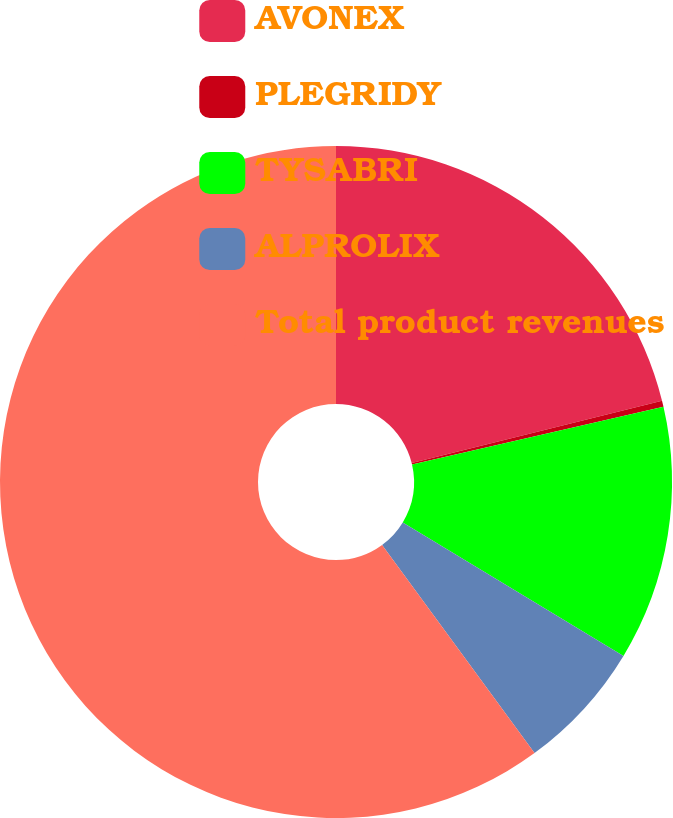Convert chart to OTSL. <chart><loc_0><loc_0><loc_500><loc_500><pie_chart><fcel>AVONEX<fcel>PLEGRIDY<fcel>TYSABRI<fcel>ALPROLIX<fcel>Total product revenues<nl><fcel>21.11%<fcel>0.3%<fcel>12.25%<fcel>6.28%<fcel>60.06%<nl></chart> 